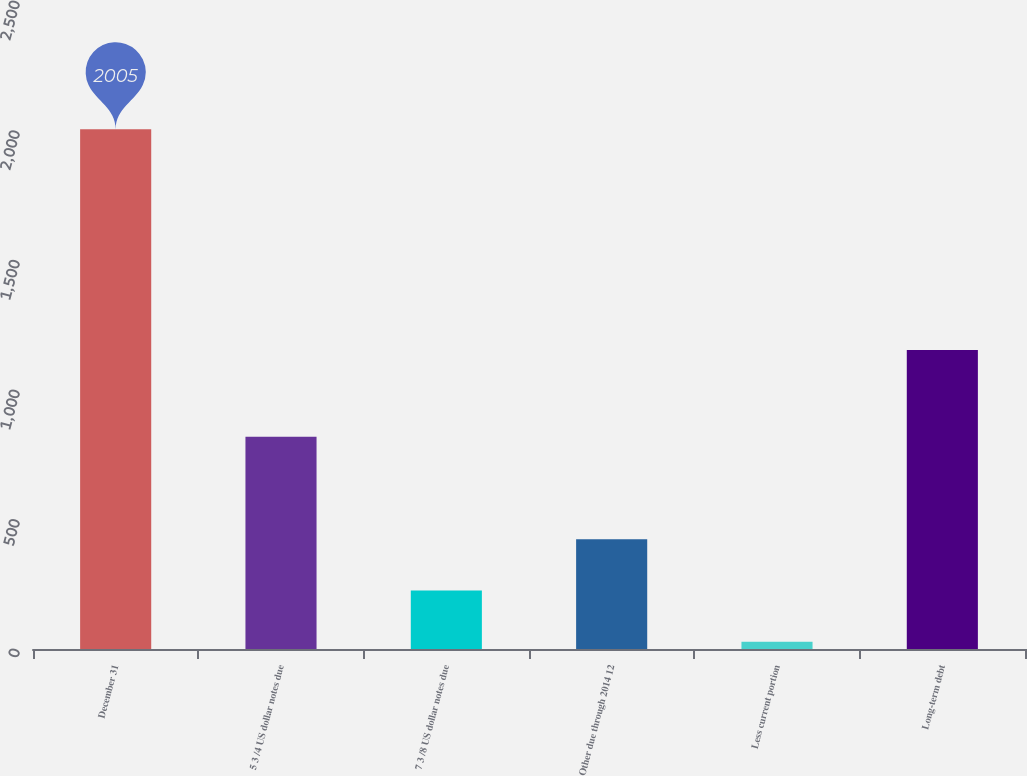<chart> <loc_0><loc_0><loc_500><loc_500><bar_chart><fcel>December 31<fcel>5 3 /4 US dollar notes due<fcel>7 3 /8 US dollar notes due<fcel>Other due through 2014 12<fcel>Less current portion<fcel>Long-term debt<nl><fcel>2005<fcel>818.8<fcel>225.7<fcel>423.4<fcel>28<fcel>1154<nl></chart> 